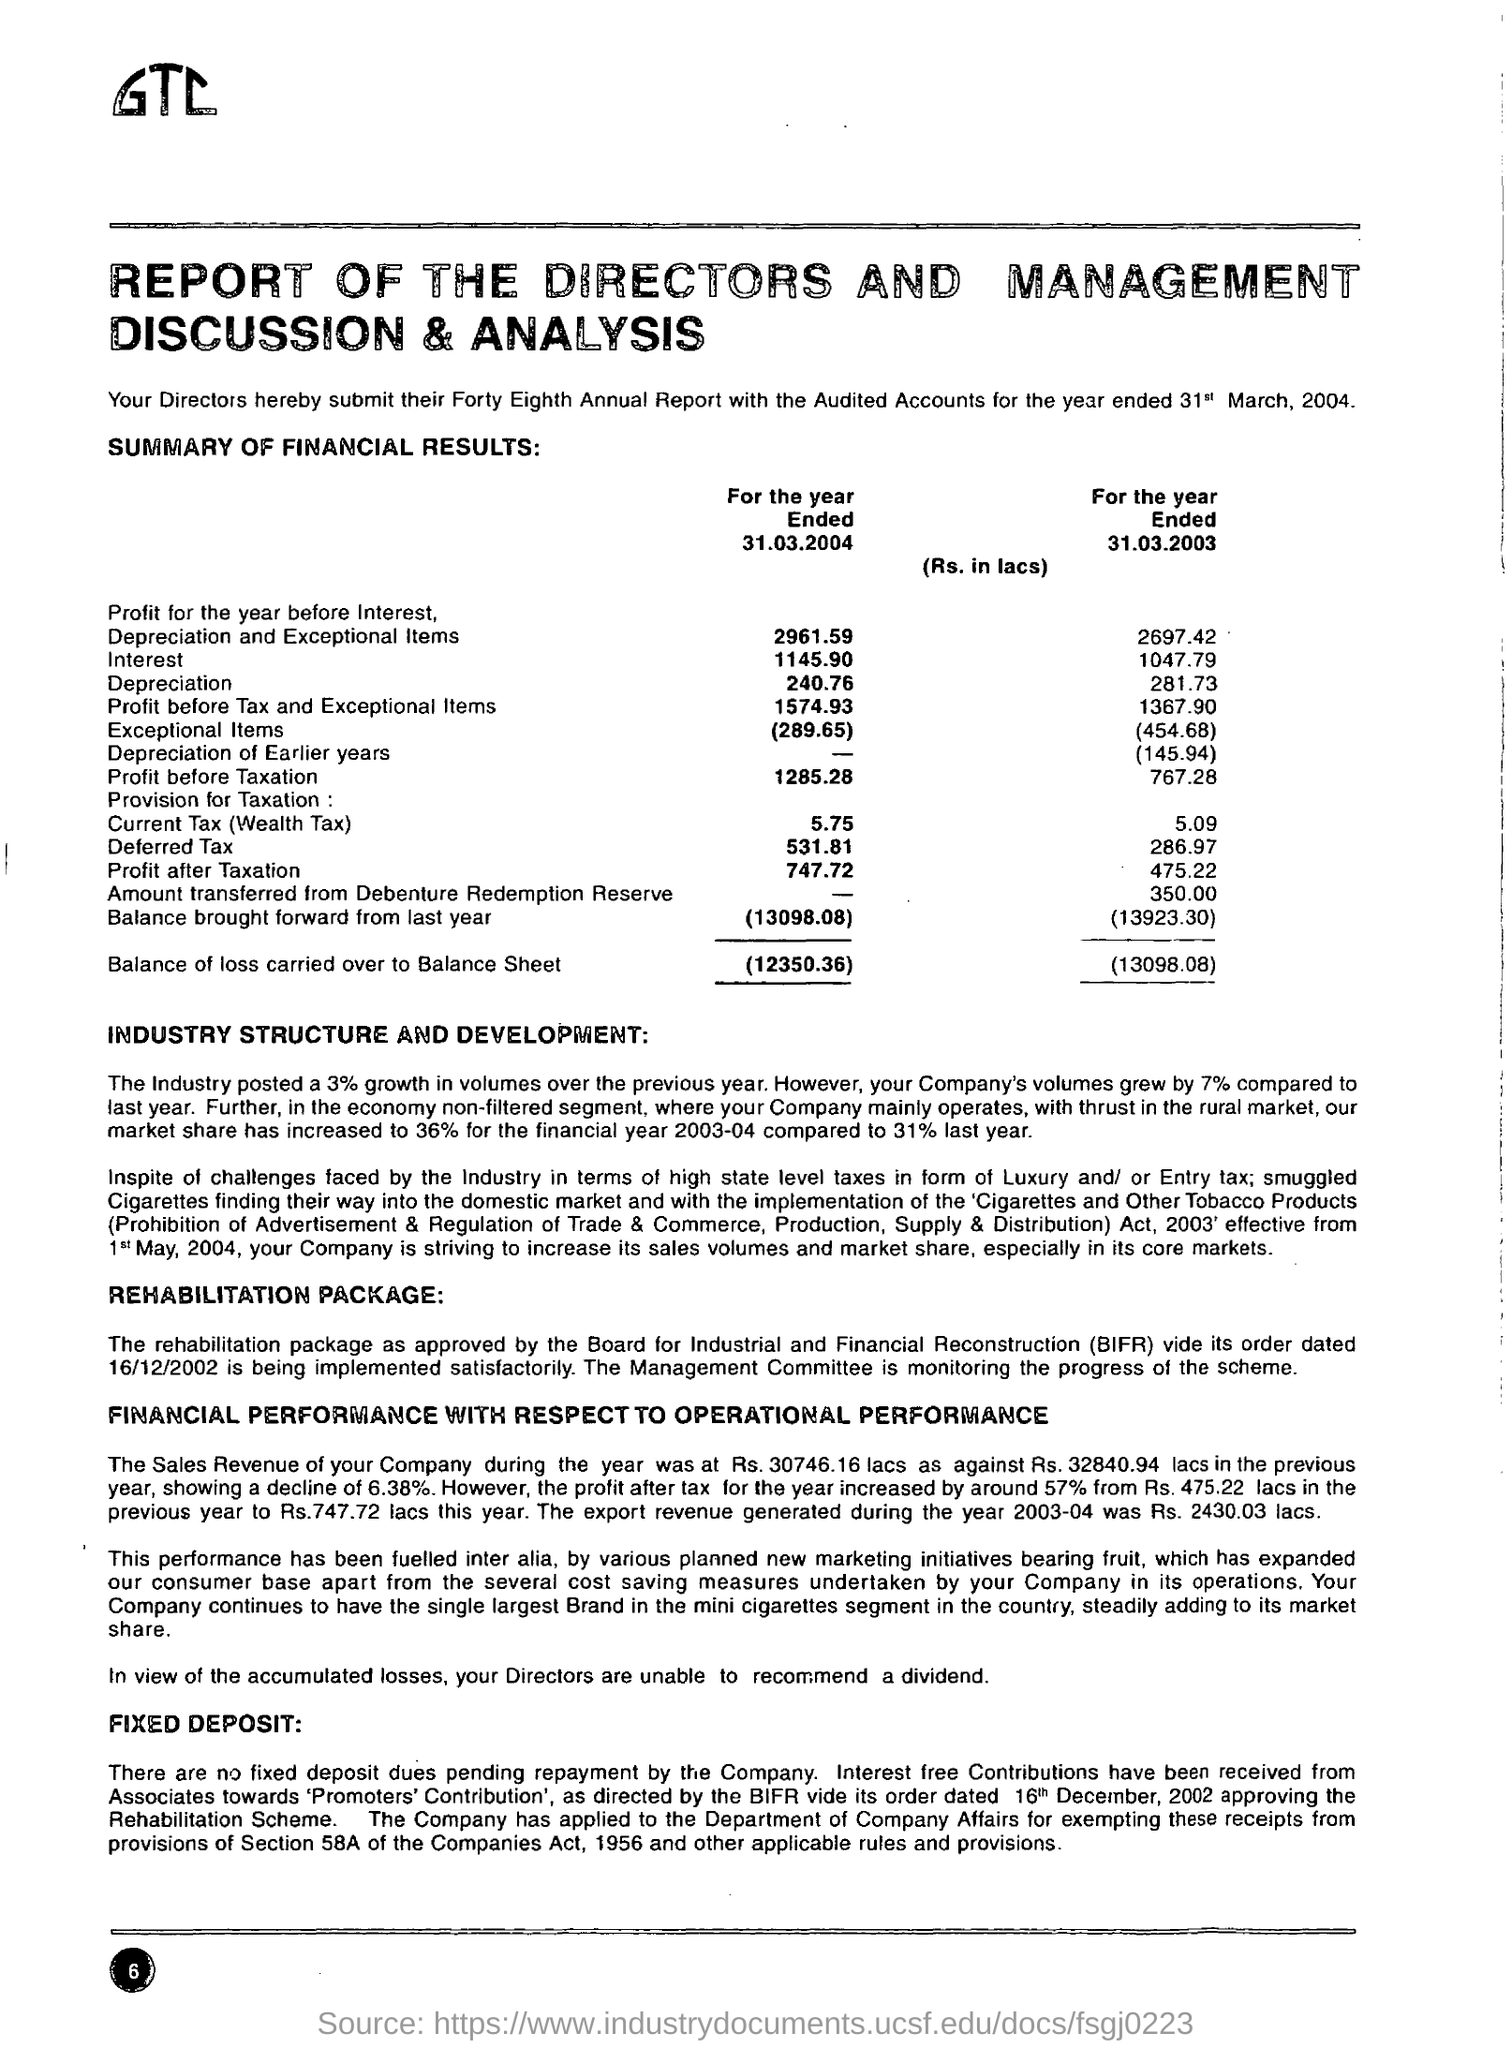Identify some key points in this picture. The depreciation shown in the report for the year ended 31.03.2003 is 281.73 lacs. The market share of the financial year 2003-04 increased by 36% compared to the previous year. The amount of interest for the year ended March 31, 2003 was Rs. 1047.79 crores. The directors submitted the 48th annual report with audited accounts for the year ended March 31, 2004, which contains critical information about the company's financial performance and operations during the year. The depreciation and exceptional items shown in the report for the year ended 31.03.2004 are 2961.59 Rupees in lacs. 